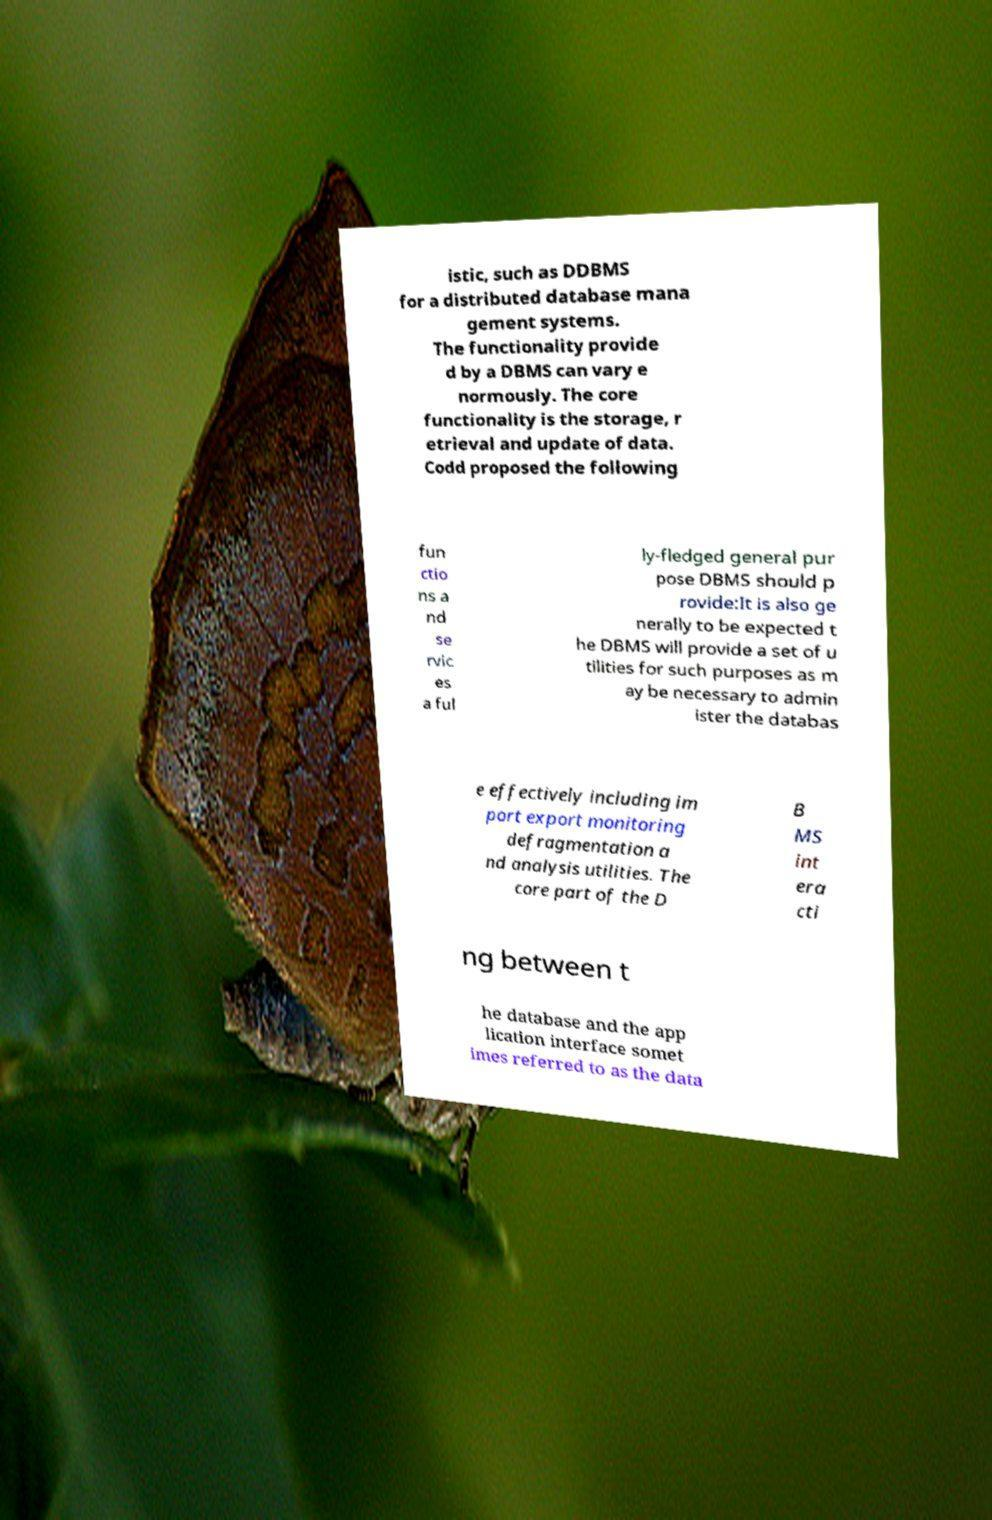Could you assist in decoding the text presented in this image and type it out clearly? istic, such as DDBMS for a distributed database mana gement systems. The functionality provide d by a DBMS can vary e normously. The core functionality is the storage, r etrieval and update of data. Codd proposed the following fun ctio ns a nd se rvic es a ful ly-fledged general pur pose DBMS should p rovide:It is also ge nerally to be expected t he DBMS will provide a set of u tilities for such purposes as m ay be necessary to admin ister the databas e effectively including im port export monitoring defragmentation a nd analysis utilities. The core part of the D B MS int era cti ng between t he database and the app lication interface somet imes referred to as the data 